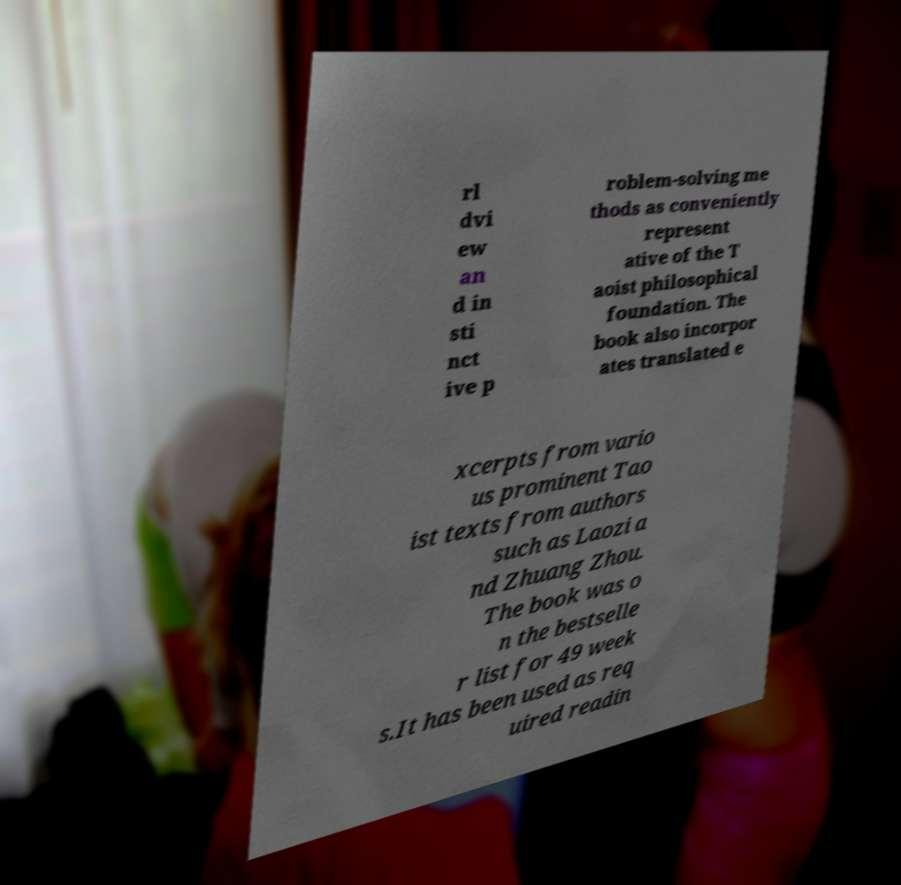What messages or text are displayed in this image? I need them in a readable, typed format. rl dvi ew an d in sti nct ive p roblem-solving me thods as conveniently represent ative of the T aoist philosophical foundation. The book also incorpor ates translated e xcerpts from vario us prominent Tao ist texts from authors such as Laozi a nd Zhuang Zhou. The book was o n the bestselle r list for 49 week s.It has been used as req uired readin 